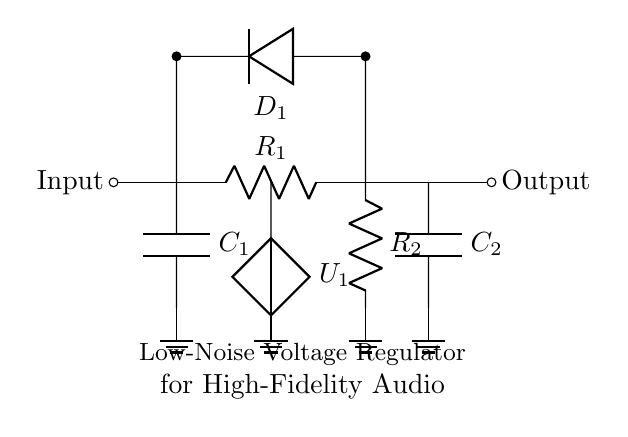What is the input component in this circuit? The input component is represented by the terminal marked "Input," which connects to a resistor labeled R1.
Answer: R1 What does C1 represent in this circuit? C1 is a capacitor connected to ground, which indicates it functions as a filter to smooth out voltage fluctuations.
Answer: Capacitor What is the function of D1 in this circuit? D1 is a diode that allows current to pass in one direction, ensuring that the output voltage is regulated and does not drop below a certain level.
Answer: Diode What is the purpose of the resistors R1 and R2? R1 is typically part of a voltage divider that helps set the output voltage, while R2 works in tandem to ensure stable performance of the regulator.
Answer: Voltage setting If the voltage source is U1, what is its role in the circuit? U1, which is a voltage source, provides the necessary power for the circuit; it ensures that voltage enters the system for regulation.
Answer: Voltage source What type of circuit is this? This circuit is designed to regulate voltage for high-fidelity audio applications, specifically functioning as a low-noise voltage regulator.
Answer: Regulator 